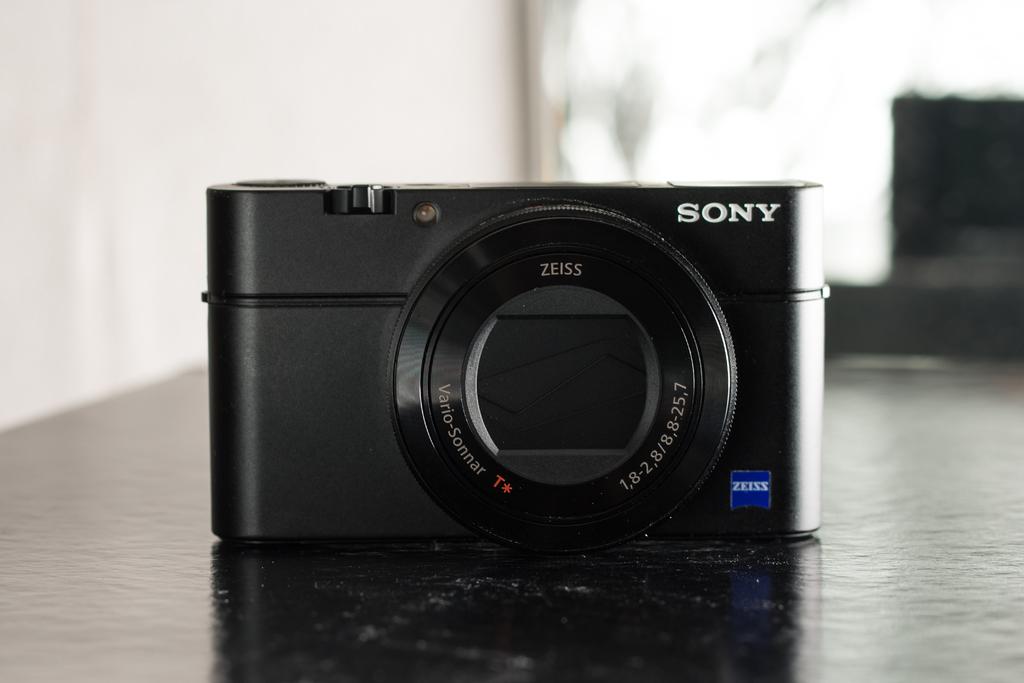What brand is this camera?
Provide a succinct answer. Sony. 